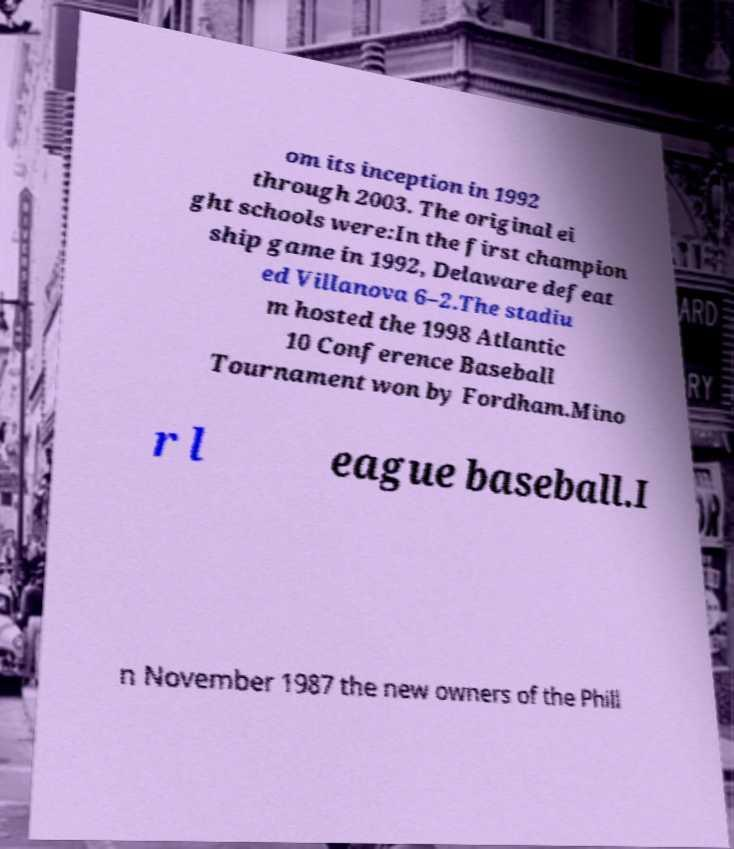Could you assist in decoding the text presented in this image and type it out clearly? om its inception in 1992 through 2003. The original ei ght schools were:In the first champion ship game in 1992, Delaware defeat ed Villanova 6–2.The stadiu m hosted the 1998 Atlantic 10 Conference Baseball Tournament won by Fordham.Mino r l eague baseball.I n November 1987 the new owners of the Phill 